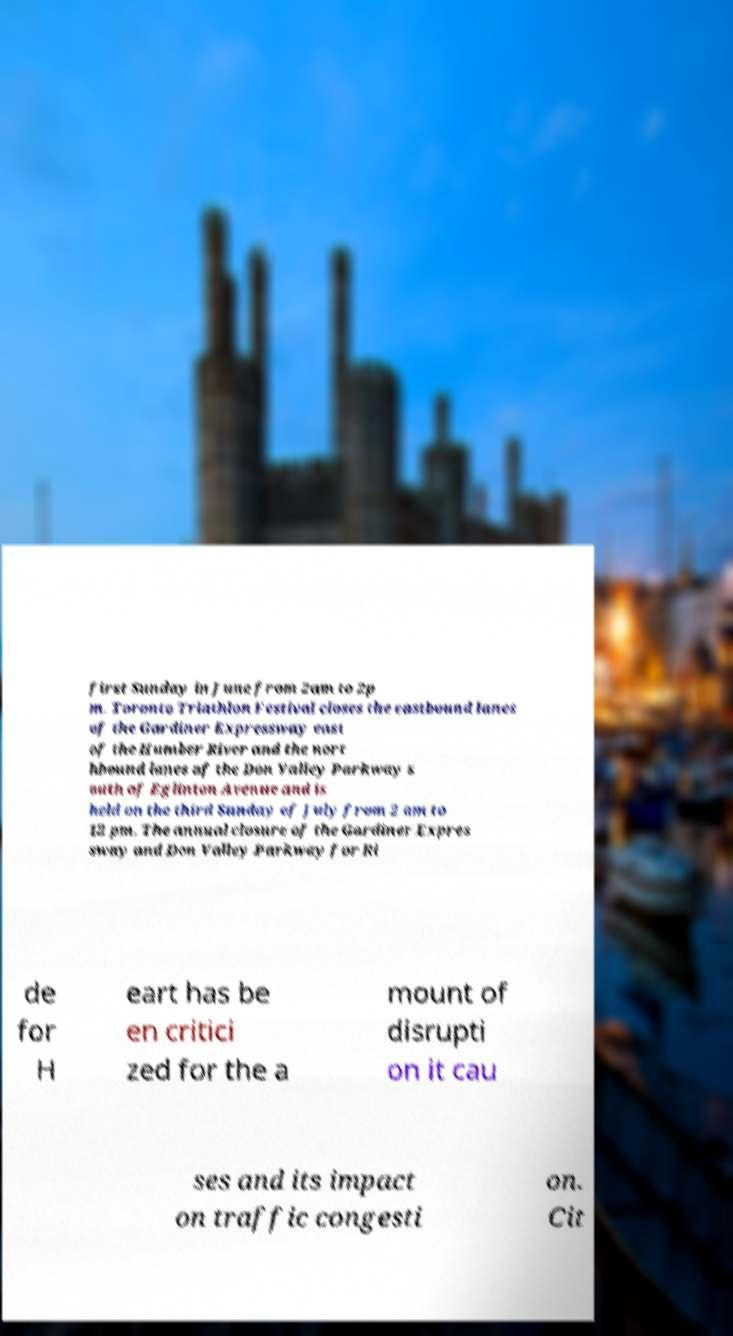For documentation purposes, I need the text within this image transcribed. Could you provide that? first Sunday in June from 2am to 2p m. Toronto Triathlon Festival closes the eastbound lanes of the Gardiner Expressway east of the Humber River and the nort hbound lanes of the Don Valley Parkway s outh of Eglinton Avenue and is held on the third Sunday of July from 2 am to 12 pm. The annual closure of the Gardiner Expres sway and Don Valley Parkway for Ri de for H eart has be en critici zed for the a mount of disrupti on it cau ses and its impact on traffic congesti on. Cit 